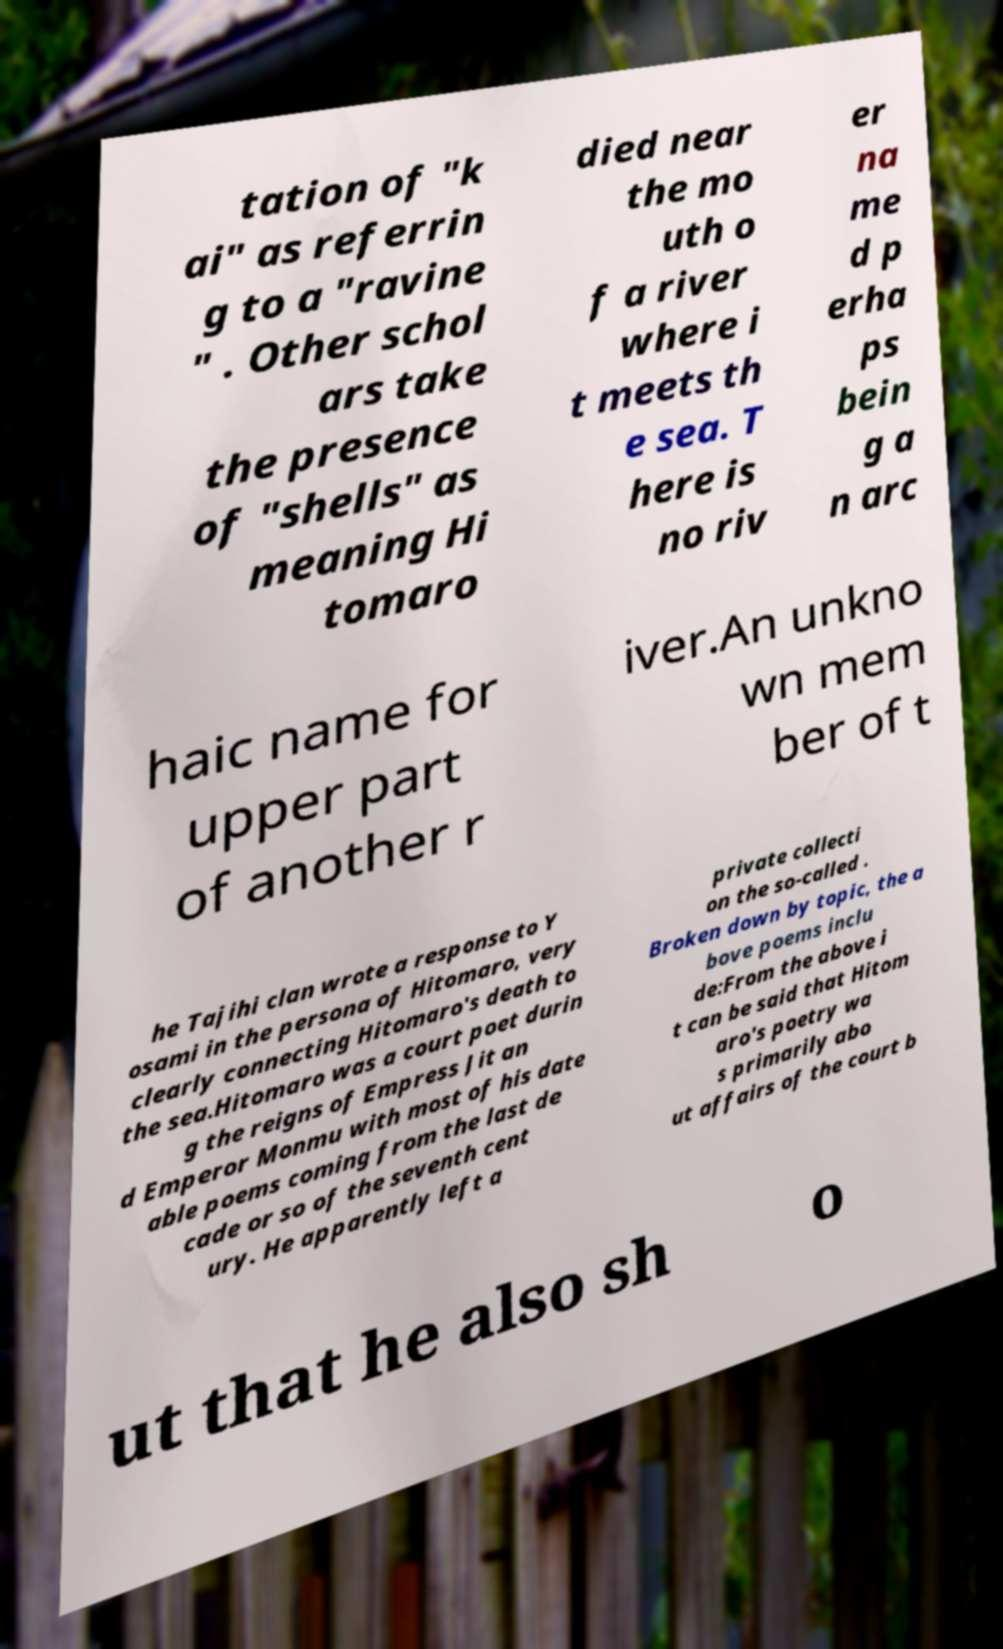Can you read and provide the text displayed in the image?This photo seems to have some interesting text. Can you extract and type it out for me? tation of "k ai" as referrin g to a "ravine " . Other schol ars take the presence of "shells" as meaning Hi tomaro died near the mo uth o f a river where i t meets th e sea. T here is no riv er na me d p erha ps bein g a n arc haic name for upper part of another r iver.An unkno wn mem ber of t he Tajihi clan wrote a response to Y osami in the persona of Hitomaro, very clearly connecting Hitomaro's death to the sea.Hitomaro was a court poet durin g the reigns of Empress Jit an d Emperor Monmu with most of his date able poems coming from the last de cade or so of the seventh cent ury. He apparently left a private collecti on the so-called . Broken down by topic, the a bove poems inclu de:From the above i t can be said that Hitom aro's poetry wa s primarily abo ut affairs of the court b ut that he also sh o 